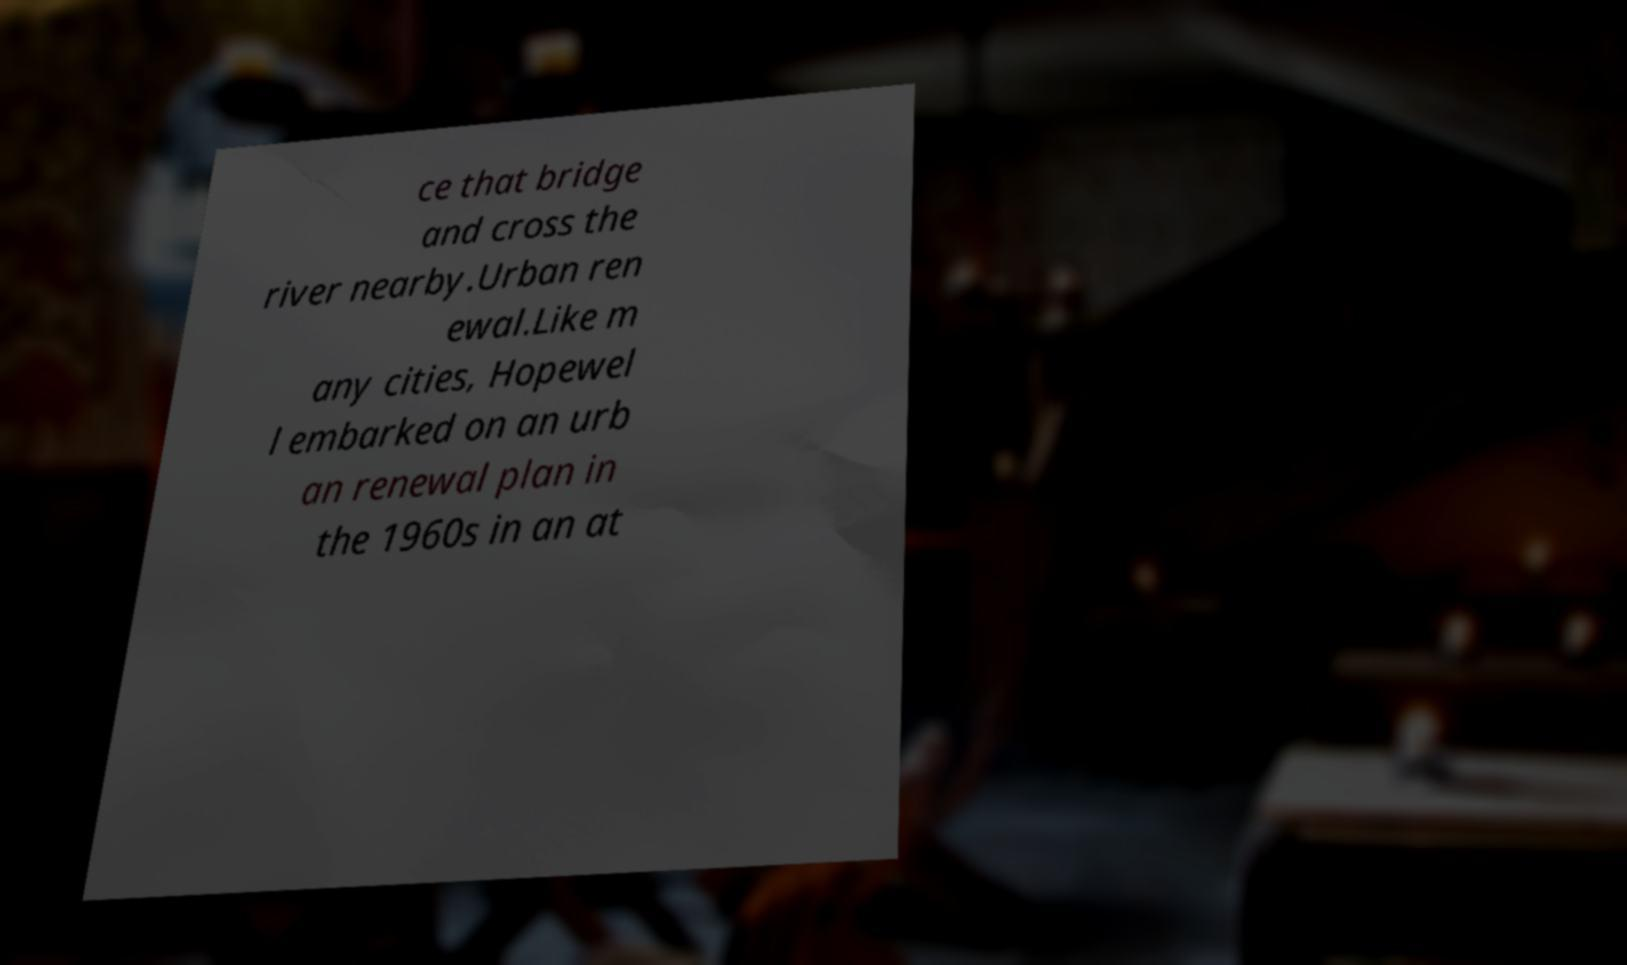What messages or text are displayed in this image? I need them in a readable, typed format. ce that bridge and cross the river nearby.Urban ren ewal.Like m any cities, Hopewel l embarked on an urb an renewal plan in the 1960s in an at 